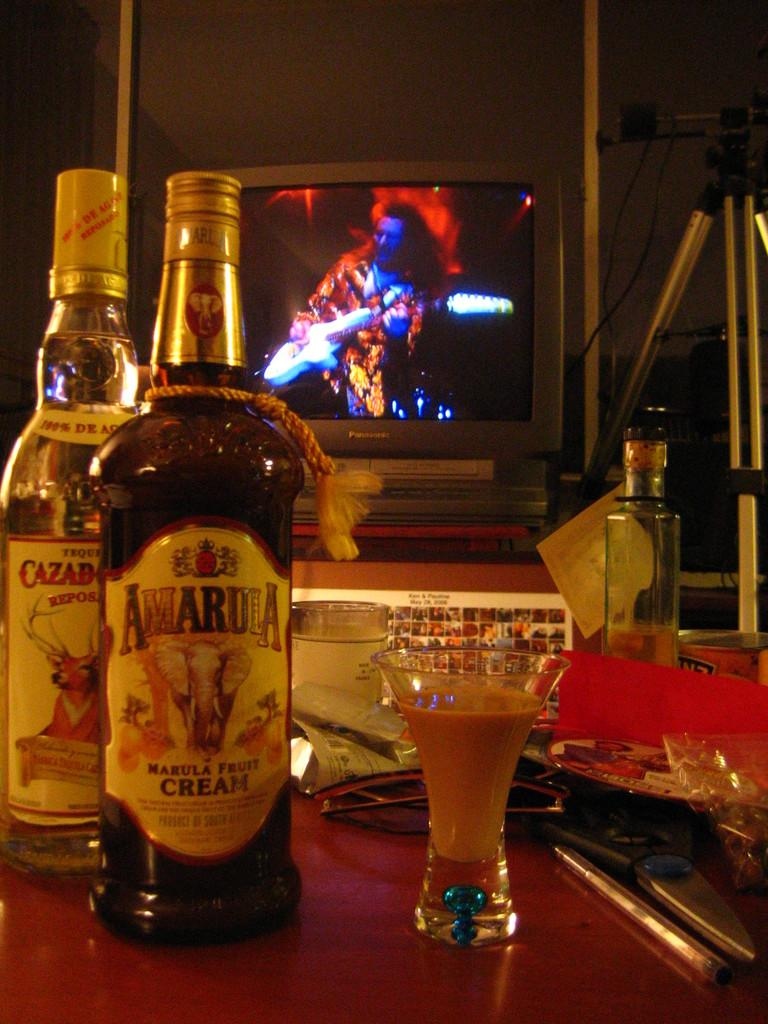<image>
Share a concise interpretation of the image provided. Awardia Marula Fruit Cream bottle that is on a table. 